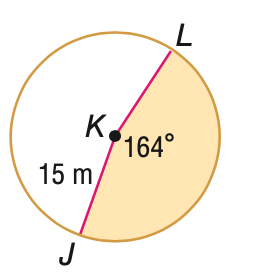Question: Find the area of the shaded sector. Round to the nearest tenth, if necessary.
Choices:
A. 42.9
B. 51.3
C. 322.0
D. 706.9
Answer with the letter. Answer: C 